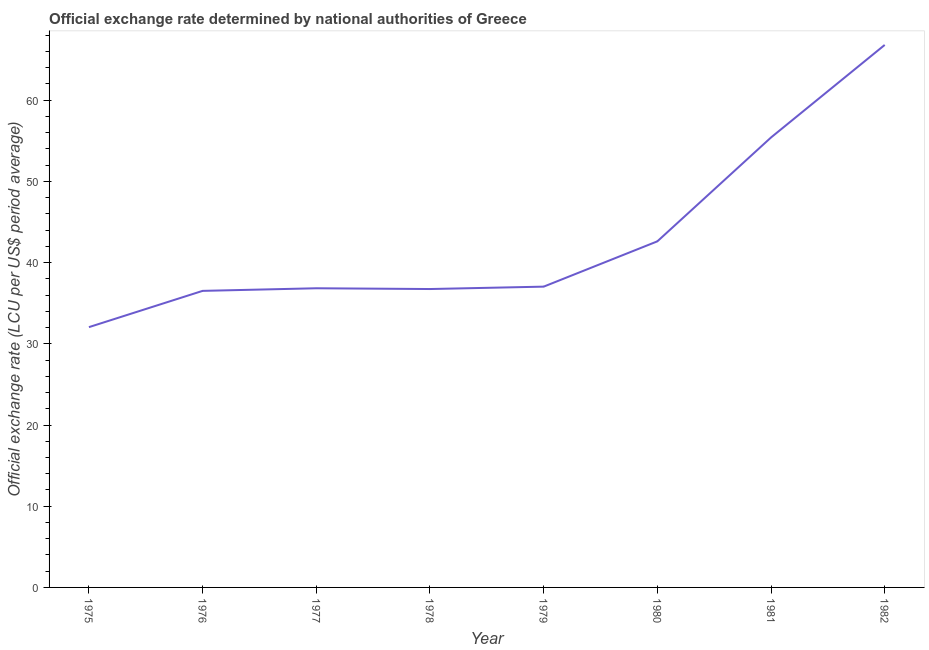What is the official exchange rate in 1975?
Your answer should be compact. 32.05. Across all years, what is the maximum official exchange rate?
Offer a very short reply. 66.8. Across all years, what is the minimum official exchange rate?
Ensure brevity in your answer.  32.05. In which year was the official exchange rate maximum?
Make the answer very short. 1982. In which year was the official exchange rate minimum?
Your answer should be very brief. 1975. What is the sum of the official exchange rate?
Provide a succinct answer. 344.02. What is the difference between the official exchange rate in 1975 and 1976?
Offer a terse response. -4.47. What is the average official exchange rate per year?
Offer a very short reply. 43. What is the median official exchange rate?
Offer a terse response. 36.94. What is the ratio of the official exchange rate in 1975 to that in 1976?
Offer a terse response. 0.88. Is the official exchange rate in 1975 less than that in 1977?
Ensure brevity in your answer.  Yes. What is the difference between the highest and the second highest official exchange rate?
Provide a succinct answer. 11.39. Is the sum of the official exchange rate in 1976 and 1980 greater than the maximum official exchange rate across all years?
Your response must be concise. Yes. What is the difference between the highest and the lowest official exchange rate?
Give a very brief answer. 34.75. How many lines are there?
Your answer should be very brief. 1. How many years are there in the graph?
Make the answer very short. 8. Does the graph contain any zero values?
Provide a short and direct response. No. Does the graph contain grids?
Keep it short and to the point. No. What is the title of the graph?
Make the answer very short. Official exchange rate determined by national authorities of Greece. What is the label or title of the X-axis?
Offer a terse response. Year. What is the label or title of the Y-axis?
Provide a short and direct response. Official exchange rate (LCU per US$ period average). What is the Official exchange rate (LCU per US$ period average) of 1975?
Ensure brevity in your answer.  32.05. What is the Official exchange rate (LCU per US$ period average) of 1976?
Offer a terse response. 36.52. What is the Official exchange rate (LCU per US$ period average) in 1977?
Keep it short and to the point. 36.84. What is the Official exchange rate (LCU per US$ period average) in 1978?
Your answer should be compact. 36.75. What is the Official exchange rate (LCU per US$ period average) of 1979?
Make the answer very short. 37.04. What is the Official exchange rate (LCU per US$ period average) in 1980?
Ensure brevity in your answer.  42.62. What is the Official exchange rate (LCU per US$ period average) in 1981?
Give a very brief answer. 55.41. What is the Official exchange rate (LCU per US$ period average) in 1982?
Offer a terse response. 66.8. What is the difference between the Official exchange rate (LCU per US$ period average) in 1975 and 1976?
Keep it short and to the point. -4.47. What is the difference between the Official exchange rate (LCU per US$ period average) in 1975 and 1977?
Ensure brevity in your answer.  -4.79. What is the difference between the Official exchange rate (LCU per US$ period average) in 1975 and 1978?
Provide a succinct answer. -4.69. What is the difference between the Official exchange rate (LCU per US$ period average) in 1975 and 1979?
Ensure brevity in your answer.  -4.99. What is the difference between the Official exchange rate (LCU per US$ period average) in 1975 and 1980?
Your answer should be very brief. -10.57. What is the difference between the Official exchange rate (LCU per US$ period average) in 1975 and 1981?
Provide a succinct answer. -23.36. What is the difference between the Official exchange rate (LCU per US$ period average) in 1975 and 1982?
Offer a terse response. -34.75. What is the difference between the Official exchange rate (LCU per US$ period average) in 1976 and 1977?
Offer a terse response. -0.32. What is the difference between the Official exchange rate (LCU per US$ period average) in 1976 and 1978?
Give a very brief answer. -0.23. What is the difference between the Official exchange rate (LCU per US$ period average) in 1976 and 1979?
Your answer should be compact. -0.52. What is the difference between the Official exchange rate (LCU per US$ period average) in 1976 and 1980?
Ensure brevity in your answer.  -6.1. What is the difference between the Official exchange rate (LCU per US$ period average) in 1976 and 1981?
Keep it short and to the point. -18.89. What is the difference between the Official exchange rate (LCU per US$ period average) in 1976 and 1982?
Provide a short and direct response. -30.29. What is the difference between the Official exchange rate (LCU per US$ period average) in 1977 and 1978?
Keep it short and to the point. 0.09. What is the difference between the Official exchange rate (LCU per US$ period average) in 1977 and 1980?
Provide a succinct answer. -5.78. What is the difference between the Official exchange rate (LCU per US$ period average) in 1977 and 1981?
Keep it short and to the point. -18.57. What is the difference between the Official exchange rate (LCU per US$ period average) in 1977 and 1982?
Give a very brief answer. -29.96. What is the difference between the Official exchange rate (LCU per US$ period average) in 1978 and 1979?
Give a very brief answer. -0.29. What is the difference between the Official exchange rate (LCU per US$ period average) in 1978 and 1980?
Provide a succinct answer. -5.87. What is the difference between the Official exchange rate (LCU per US$ period average) in 1978 and 1981?
Make the answer very short. -18.66. What is the difference between the Official exchange rate (LCU per US$ period average) in 1978 and 1982?
Offer a terse response. -30.06. What is the difference between the Official exchange rate (LCU per US$ period average) in 1979 and 1980?
Make the answer very short. -5.58. What is the difference between the Official exchange rate (LCU per US$ period average) in 1979 and 1981?
Provide a succinct answer. -18.37. What is the difference between the Official exchange rate (LCU per US$ period average) in 1979 and 1982?
Offer a very short reply. -29.76. What is the difference between the Official exchange rate (LCU per US$ period average) in 1980 and 1981?
Keep it short and to the point. -12.79. What is the difference between the Official exchange rate (LCU per US$ period average) in 1980 and 1982?
Provide a succinct answer. -24.19. What is the difference between the Official exchange rate (LCU per US$ period average) in 1981 and 1982?
Ensure brevity in your answer.  -11.39. What is the ratio of the Official exchange rate (LCU per US$ period average) in 1975 to that in 1976?
Offer a very short reply. 0.88. What is the ratio of the Official exchange rate (LCU per US$ period average) in 1975 to that in 1977?
Provide a succinct answer. 0.87. What is the ratio of the Official exchange rate (LCU per US$ period average) in 1975 to that in 1978?
Your answer should be compact. 0.87. What is the ratio of the Official exchange rate (LCU per US$ period average) in 1975 to that in 1979?
Provide a succinct answer. 0.86. What is the ratio of the Official exchange rate (LCU per US$ period average) in 1975 to that in 1980?
Offer a very short reply. 0.75. What is the ratio of the Official exchange rate (LCU per US$ period average) in 1975 to that in 1981?
Offer a terse response. 0.58. What is the ratio of the Official exchange rate (LCU per US$ period average) in 1975 to that in 1982?
Your response must be concise. 0.48. What is the ratio of the Official exchange rate (LCU per US$ period average) in 1976 to that in 1977?
Ensure brevity in your answer.  0.99. What is the ratio of the Official exchange rate (LCU per US$ period average) in 1976 to that in 1978?
Keep it short and to the point. 0.99. What is the ratio of the Official exchange rate (LCU per US$ period average) in 1976 to that in 1979?
Give a very brief answer. 0.99. What is the ratio of the Official exchange rate (LCU per US$ period average) in 1976 to that in 1980?
Offer a very short reply. 0.86. What is the ratio of the Official exchange rate (LCU per US$ period average) in 1976 to that in 1981?
Provide a succinct answer. 0.66. What is the ratio of the Official exchange rate (LCU per US$ period average) in 1976 to that in 1982?
Your response must be concise. 0.55. What is the ratio of the Official exchange rate (LCU per US$ period average) in 1977 to that in 1979?
Keep it short and to the point. 0.99. What is the ratio of the Official exchange rate (LCU per US$ period average) in 1977 to that in 1980?
Provide a succinct answer. 0.86. What is the ratio of the Official exchange rate (LCU per US$ period average) in 1977 to that in 1981?
Keep it short and to the point. 0.67. What is the ratio of the Official exchange rate (LCU per US$ period average) in 1977 to that in 1982?
Provide a short and direct response. 0.55. What is the ratio of the Official exchange rate (LCU per US$ period average) in 1978 to that in 1979?
Ensure brevity in your answer.  0.99. What is the ratio of the Official exchange rate (LCU per US$ period average) in 1978 to that in 1980?
Make the answer very short. 0.86. What is the ratio of the Official exchange rate (LCU per US$ period average) in 1978 to that in 1981?
Provide a succinct answer. 0.66. What is the ratio of the Official exchange rate (LCU per US$ period average) in 1978 to that in 1982?
Offer a very short reply. 0.55. What is the ratio of the Official exchange rate (LCU per US$ period average) in 1979 to that in 1980?
Give a very brief answer. 0.87. What is the ratio of the Official exchange rate (LCU per US$ period average) in 1979 to that in 1981?
Make the answer very short. 0.67. What is the ratio of the Official exchange rate (LCU per US$ period average) in 1979 to that in 1982?
Your answer should be compact. 0.55. What is the ratio of the Official exchange rate (LCU per US$ period average) in 1980 to that in 1981?
Keep it short and to the point. 0.77. What is the ratio of the Official exchange rate (LCU per US$ period average) in 1980 to that in 1982?
Ensure brevity in your answer.  0.64. What is the ratio of the Official exchange rate (LCU per US$ period average) in 1981 to that in 1982?
Keep it short and to the point. 0.83. 